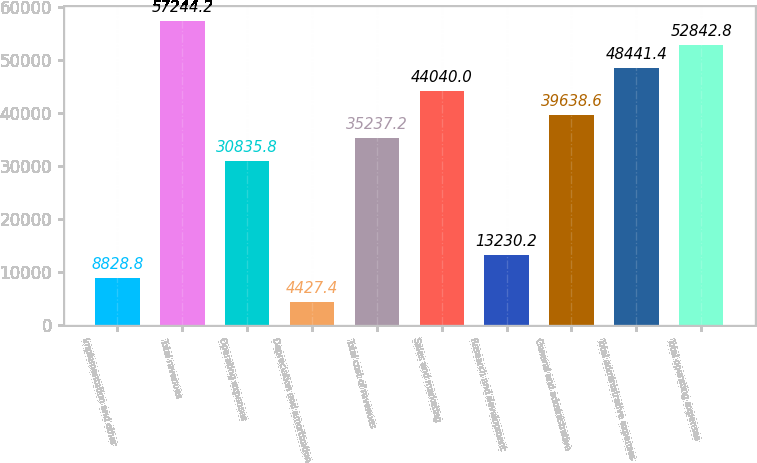Convert chart. <chart><loc_0><loc_0><loc_500><loc_500><bar_chart><fcel>Implementation and other<fcel>Total revenues<fcel>Operating expenses<fcel>Depreciation and amortization<fcel>Total cost of revenues<fcel>Sales and marketing<fcel>Research and development<fcel>General and administrative<fcel>Total administrative expenses<fcel>Total operating expenses<nl><fcel>8828.8<fcel>57244.2<fcel>30835.8<fcel>4427.4<fcel>35237.2<fcel>44040<fcel>13230.2<fcel>39638.6<fcel>48441.4<fcel>52842.8<nl></chart> 